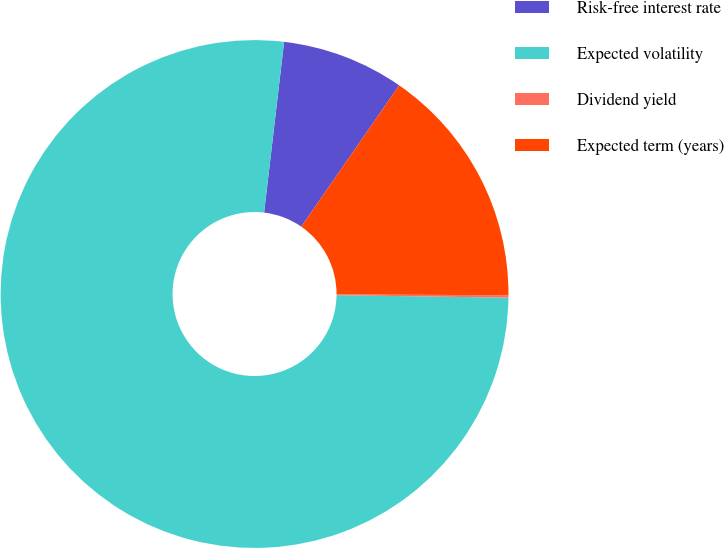Convert chart. <chart><loc_0><loc_0><loc_500><loc_500><pie_chart><fcel>Risk-free interest rate<fcel>Expected volatility<fcel>Dividend yield<fcel>Expected term (years)<nl><fcel>7.79%<fcel>76.63%<fcel>0.15%<fcel>15.43%<nl></chart> 